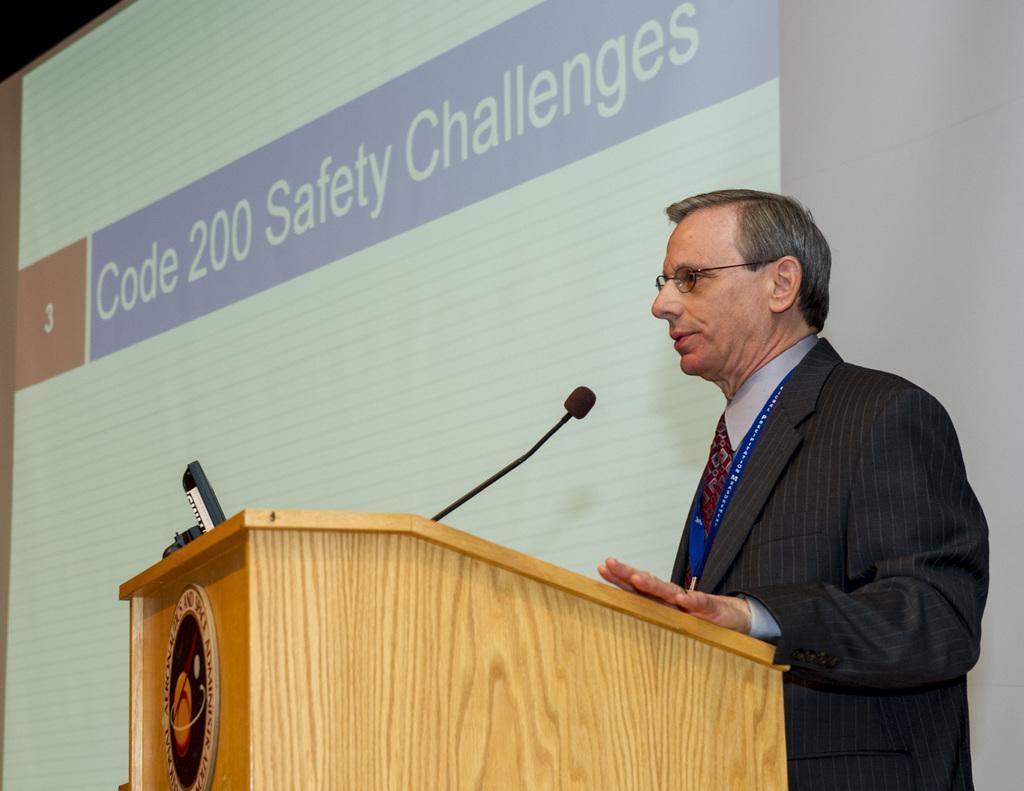Describe this image in one or two sentences. In this image I can see a person standing. There is a mike and there are some objects on the podium. In the background there is a screen. 